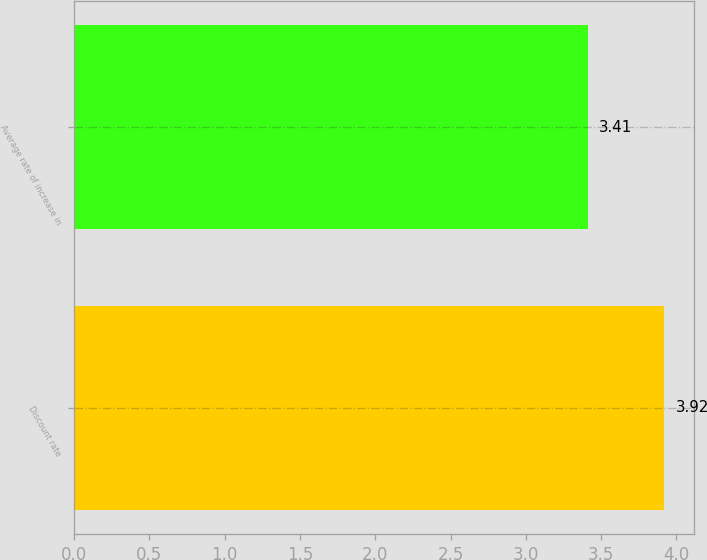<chart> <loc_0><loc_0><loc_500><loc_500><bar_chart><fcel>Discount rate<fcel>Average rate of increase in<nl><fcel>3.92<fcel>3.41<nl></chart> 